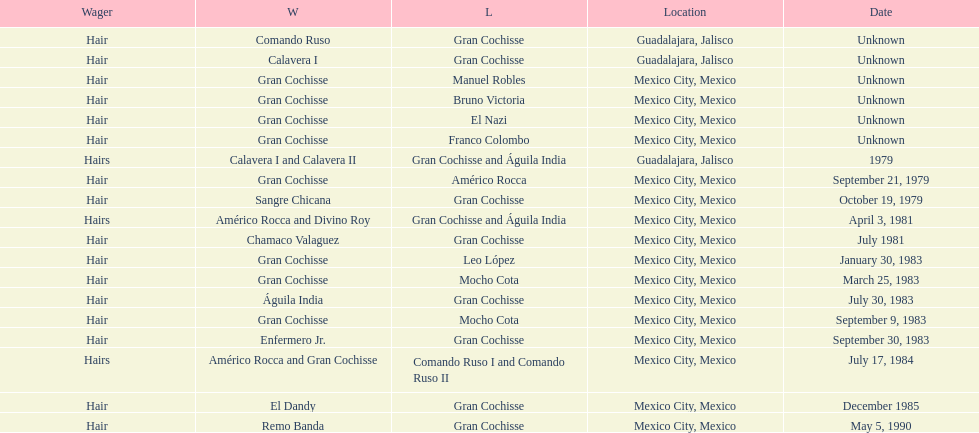Help me parse the entirety of this table. {'header': ['Wager', 'W', 'L', 'Location', 'Date'], 'rows': [['Hair', 'Comando Ruso', 'Gran Cochisse', 'Guadalajara, Jalisco', 'Unknown'], ['Hair', 'Calavera I', 'Gran Cochisse', 'Guadalajara, Jalisco', 'Unknown'], ['Hair', 'Gran Cochisse', 'Manuel Robles', 'Mexico City, Mexico', 'Unknown'], ['Hair', 'Gran Cochisse', 'Bruno Victoria', 'Mexico City, Mexico', 'Unknown'], ['Hair', 'Gran Cochisse', 'El Nazi', 'Mexico City, Mexico', 'Unknown'], ['Hair', 'Gran Cochisse', 'Franco Colombo', 'Mexico City, Mexico', 'Unknown'], ['Hairs', 'Calavera I and Calavera II', 'Gran Cochisse and Águila India', 'Guadalajara, Jalisco', '1979'], ['Hair', 'Gran Cochisse', 'Américo Rocca', 'Mexico City, Mexico', 'September 21, 1979'], ['Hair', 'Sangre Chicana', 'Gran Cochisse', 'Mexico City, Mexico', 'October 19, 1979'], ['Hairs', 'Américo Rocca and Divino Roy', 'Gran Cochisse and Águila India', 'Mexico City, Mexico', 'April 3, 1981'], ['Hair', 'Chamaco Valaguez', 'Gran Cochisse', 'Mexico City, Mexico', 'July 1981'], ['Hair', 'Gran Cochisse', 'Leo López', 'Mexico City, Mexico', 'January 30, 1983'], ['Hair', 'Gran Cochisse', 'Mocho Cota', 'Mexico City, Mexico', 'March 25, 1983'], ['Hair', 'Águila India', 'Gran Cochisse', 'Mexico City, Mexico', 'July 30, 1983'], ['Hair', 'Gran Cochisse', 'Mocho Cota', 'Mexico City, Mexico', 'September 9, 1983'], ['Hair', 'Enfermero Jr.', 'Gran Cochisse', 'Mexico City, Mexico', 'September 30, 1983'], ['Hairs', 'Américo Rocca and Gran Cochisse', 'Comando Ruso I and Comando Ruso II', 'Mexico City, Mexico', 'July 17, 1984'], ['Hair', 'El Dandy', 'Gran Cochisse', 'Mexico City, Mexico', 'December 1985'], ['Hair', 'Remo Banda', 'Gran Cochisse', 'Mexico City, Mexico', 'May 5, 1990']]} How many winners were there before bruno victoria lost? 3. 